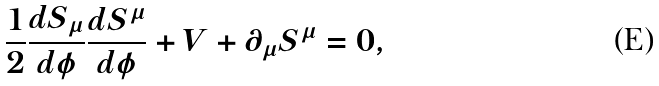<formula> <loc_0><loc_0><loc_500><loc_500>\frac { 1 } { 2 } \frac { d S _ { \mu } } { d \phi } \frac { d S ^ { \mu } } { d \phi } + V + \partial _ { \mu } S ^ { \mu } = 0 ,</formula> 